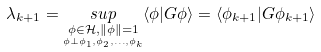<formula> <loc_0><loc_0><loc_500><loc_500>\lambda _ { k + 1 } = \underset { \underset { \phi \bot \phi _ { 1 } , \phi _ { 2 } , \dots , \phi _ { k } } { \phi \in \mathcal { H } , \| \phi \| = 1 } } { s u p } \langle \phi | G \phi \rangle = \langle \phi _ { k + 1 } | G \phi _ { k + 1 } \rangle</formula> 